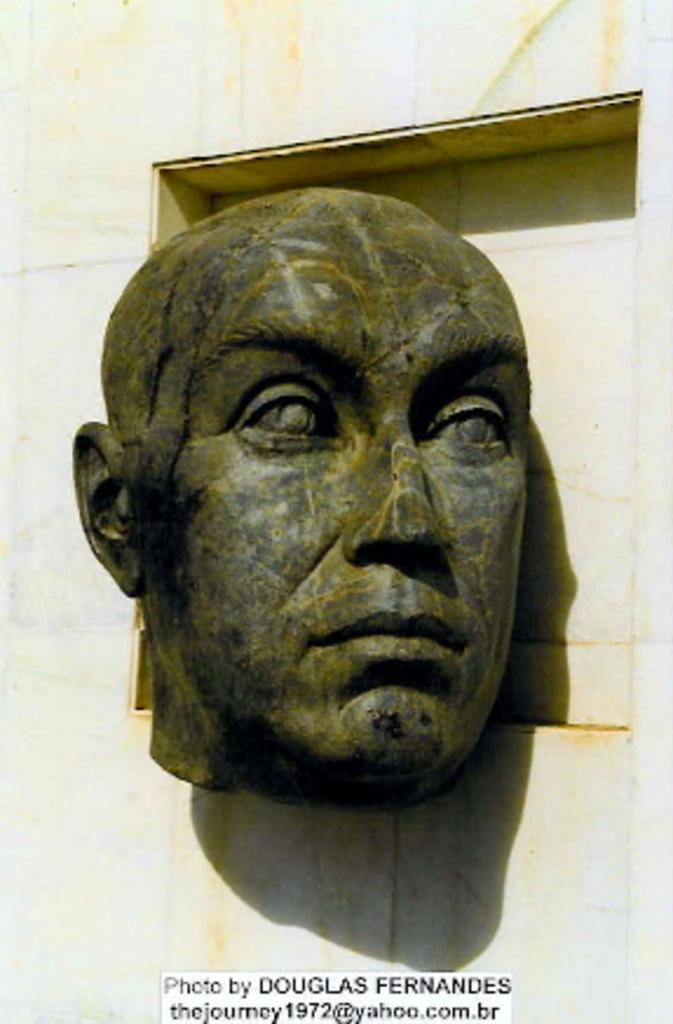What is depicted on the wall in the image? There is a sculpture of a person's face on the wall in the image. What is present at the bottom of the sculpture in the image? There is a text at the bottom of the sculpture in the image. What type of silk material is draped over the sculpture in the image? There is no silk material present in the image; it only features a sculpture of a person's face and a text at the bottom. 